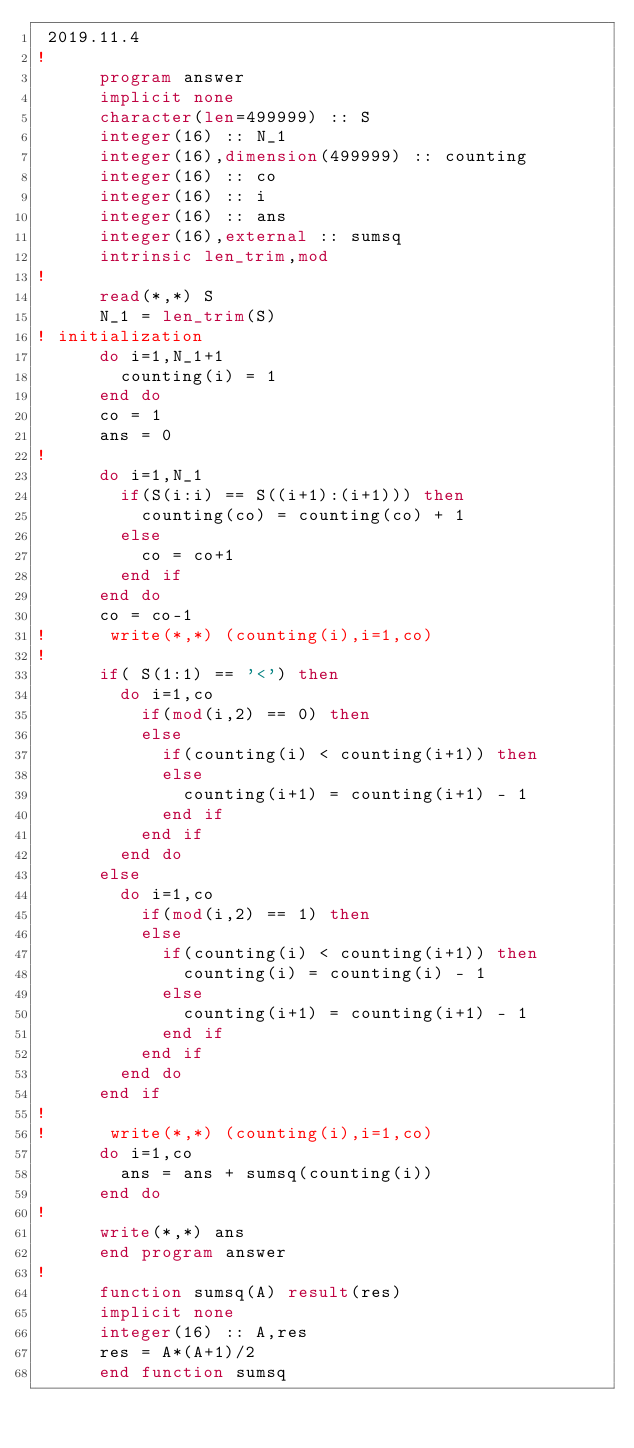Convert code to text. <code><loc_0><loc_0><loc_500><loc_500><_FORTRAN_> 2019.11.4
!
      program answer
      implicit none
      character(len=499999) :: S
      integer(16) :: N_1
      integer(16),dimension(499999) :: counting
      integer(16) :: co
      integer(16) :: i
      integer(16) :: ans
      integer(16),external :: sumsq
      intrinsic len_trim,mod
!
      read(*,*) S
      N_1 = len_trim(S)
! initialization
      do i=1,N_1+1
        counting(i) = 1
      end do
      co = 1
      ans = 0
!
      do i=1,N_1
        if(S(i:i) == S((i+1):(i+1))) then
          counting(co) = counting(co) + 1
        else
          co = co+1
        end if
      end do
      co = co-1
!      write(*,*) (counting(i),i=1,co)
!
      if( S(1:1) == '<') then
        do i=1,co
          if(mod(i,2) == 0) then
          else
            if(counting(i) < counting(i+1)) then
            else
              counting(i+1) = counting(i+1) - 1
            end if
          end if
        end do
      else
        do i=1,co
          if(mod(i,2) == 1) then
          else
            if(counting(i) < counting(i+1)) then
              counting(i) = counting(i) - 1
            else
              counting(i+1) = counting(i+1) - 1
            end if
          end if
        end do
      end if
!
!      write(*,*) (counting(i),i=1,co)
      do i=1,co
        ans = ans + sumsq(counting(i))
      end do
!
      write(*,*) ans
      end program answer
!
      function sumsq(A) result(res)
      implicit none
      integer(16) :: A,res
      res = A*(A+1)/2
      end function sumsq </code> 